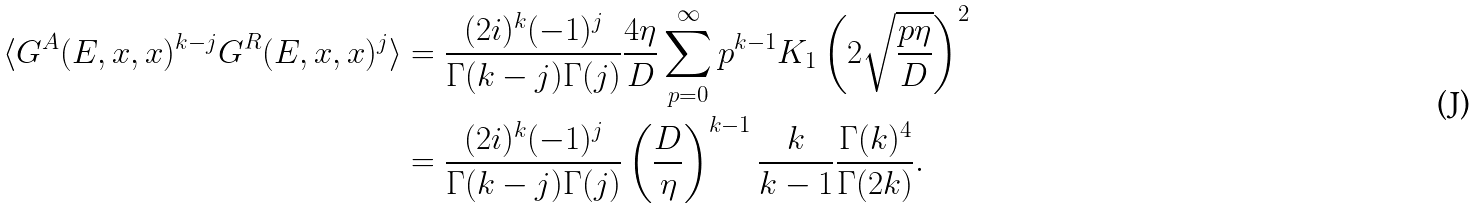Convert formula to latex. <formula><loc_0><loc_0><loc_500><loc_500>\langle G ^ { A } ( E , x , x ) ^ { k - j } G ^ { R } ( E , x , x ) ^ { j } \rangle & = \frac { ( 2 i ) ^ { k } ( - 1 ) ^ { j } } { \Gamma ( k - j ) \Gamma ( j ) } \frac { 4 \eta } { D } \sum _ { p = 0 } ^ { \infty } p ^ { k - 1 } K _ { 1 } \left ( 2 \sqrt { \frac { p \eta } { D } } \right ) ^ { 2 } \\ & = \frac { ( 2 i ) ^ { k } ( - 1 ) ^ { j } } { \Gamma ( k - j ) \Gamma ( j ) } \left ( \frac { D } { \eta } \right ) ^ { k - 1 } \frac { k } { k - 1 } \frac { \Gamma ( k ) ^ { 4 } } { \Gamma ( 2 k ) } .</formula> 